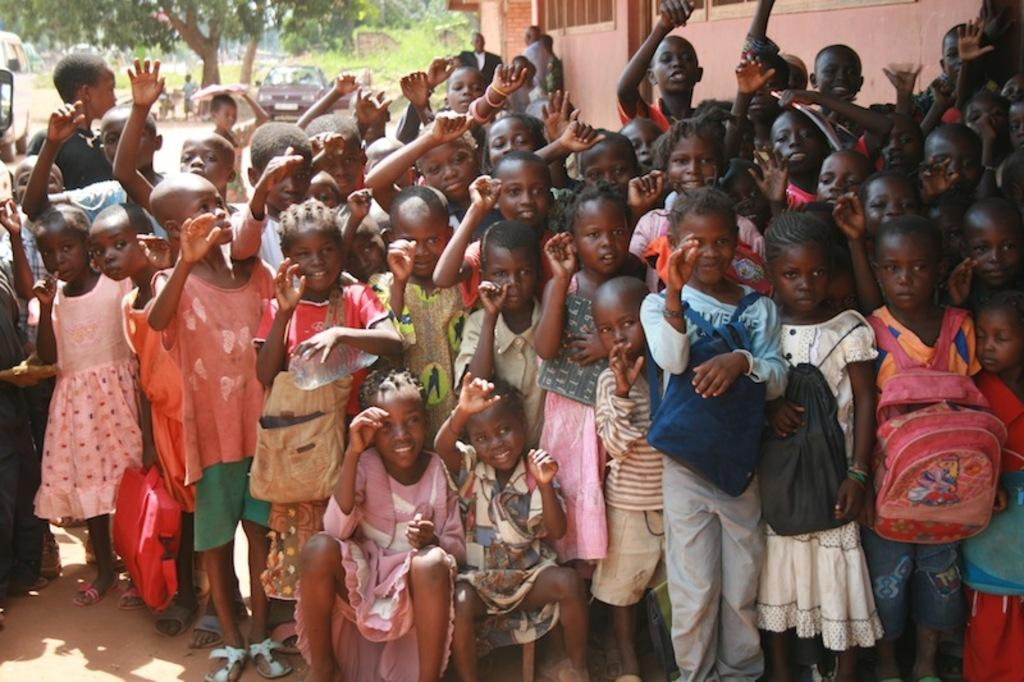What is the main subject of the image? The main subject of the image is a group of children. What are the children doing in the image? The children are standing and raising their hands. What can be seen on the right side of the image? There is a building on the right side of the image. What is located in the background of the image? There is a vehicle under the trees in the background of the image. What type of club is the children using to hit the ball in the image? There is no ball or club present in the image; the children are simply standing and raising their hands. 